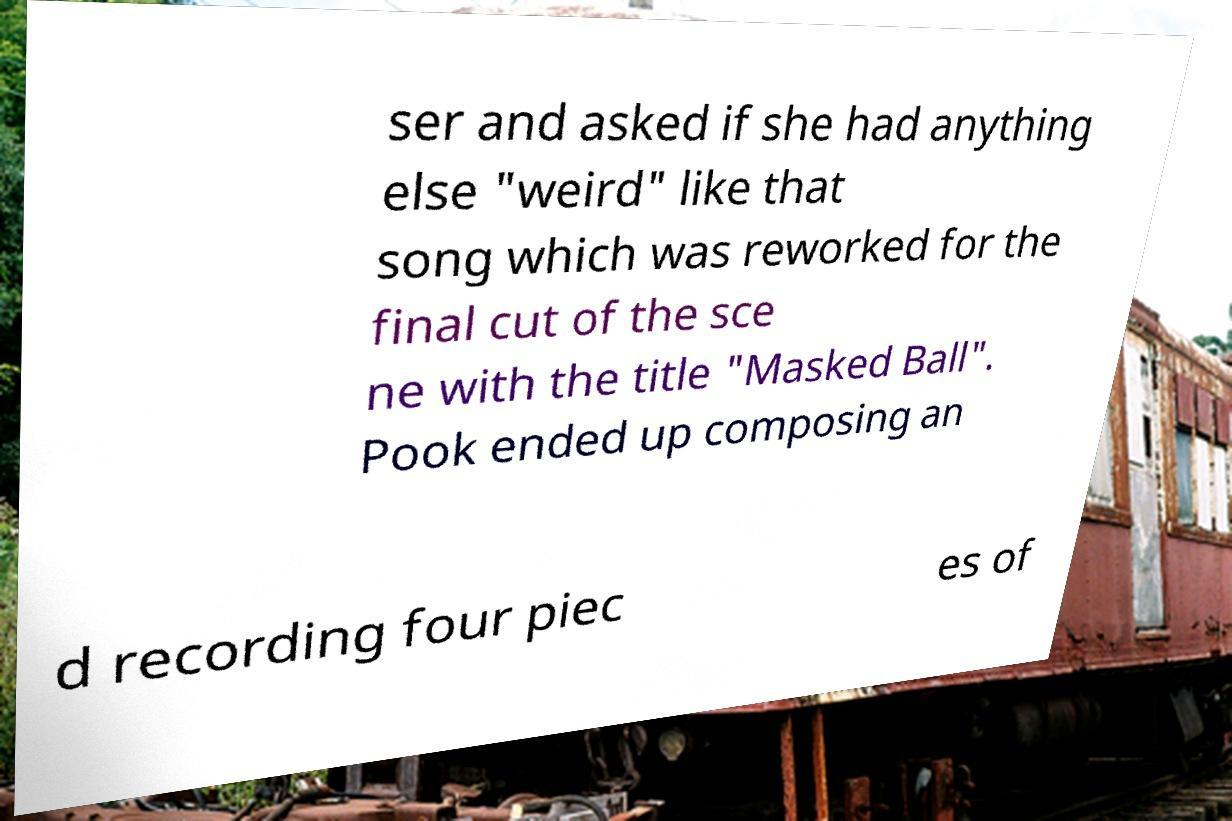Please read and relay the text visible in this image. What does it say? ser and asked if she had anything else "weird" like that song which was reworked for the final cut of the sce ne with the title "Masked Ball". Pook ended up composing an d recording four piec es of 